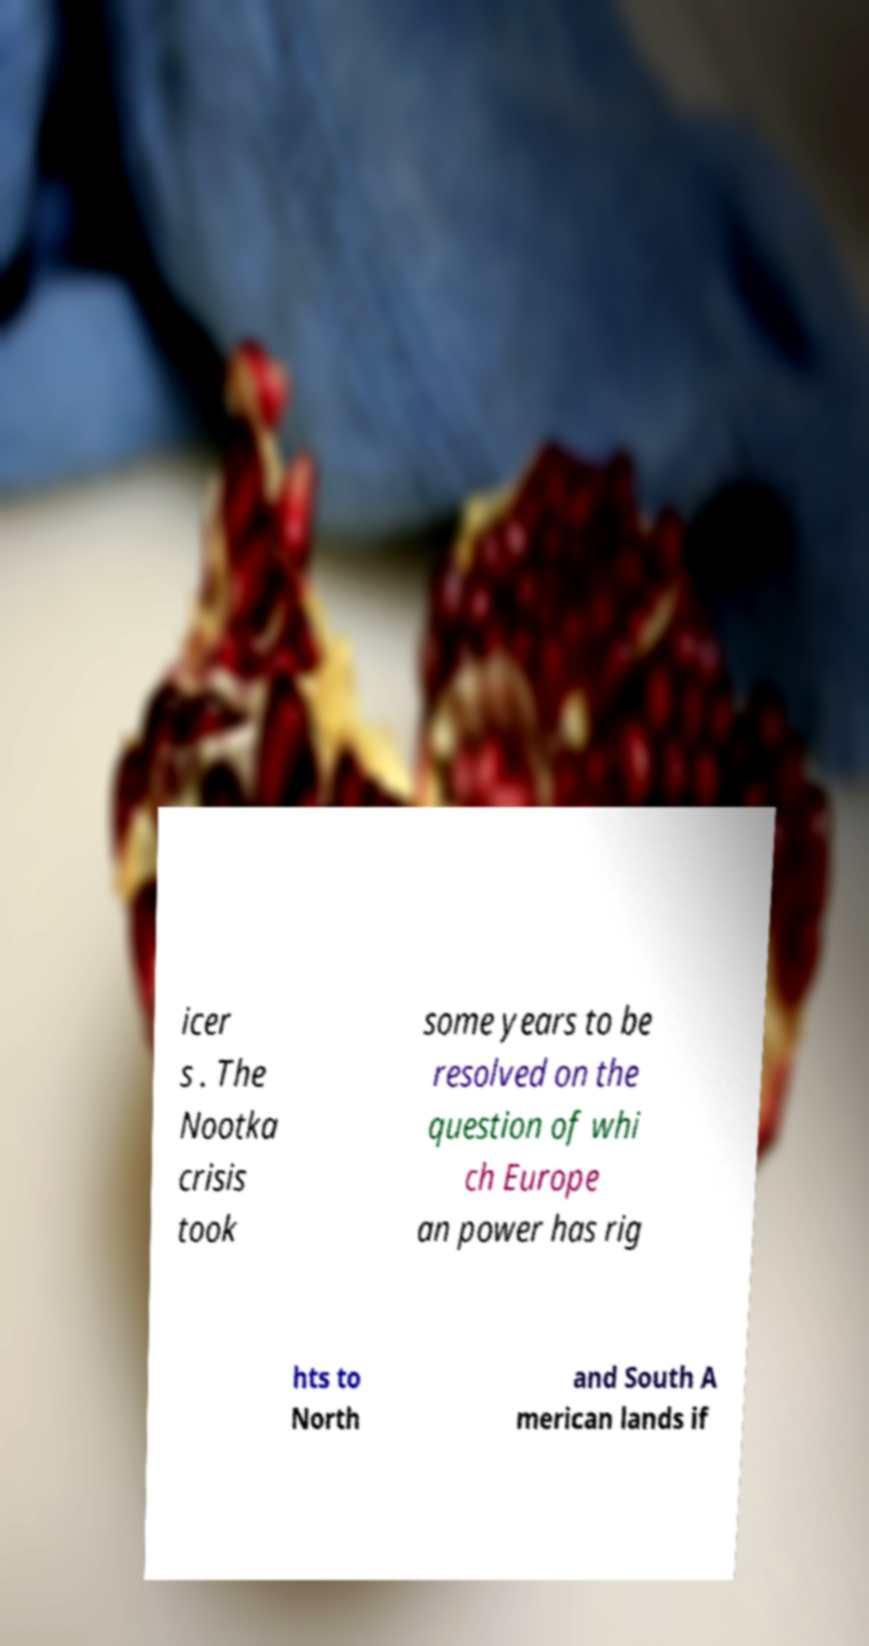Could you assist in decoding the text presented in this image and type it out clearly? icer s . The Nootka crisis took some years to be resolved on the question of whi ch Europe an power has rig hts to North and South A merican lands if 